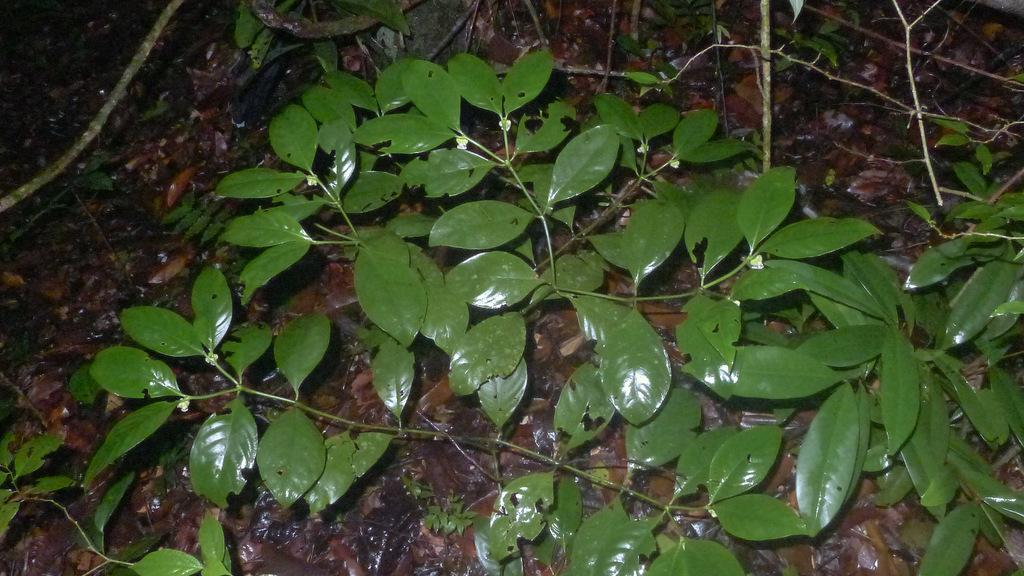What is located in the center of the image? There are plants, dry leaves, and sticks in the center of the image. What type of vegetation is present in the image? The plants in the image are not specified, but they are present in the center. What else can be seen in the center of the image besides the plants? Dry leaves and sticks are also visible in the center of the image. Where is the lunchroom located in the image? There is no lunchroom present in the image. Can you describe the friend who is sitting next to the plants in the image? There is no friend present in the image; it only features plants, dry leaves, and sticks. 